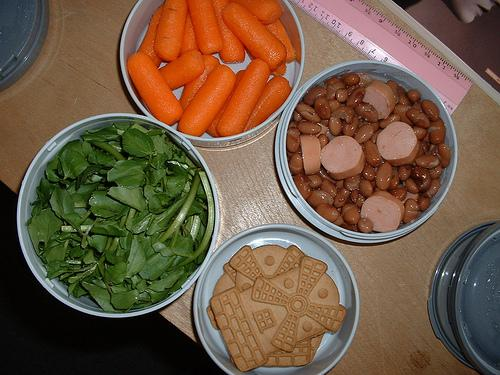What is the cookie in the shape of?

Choices:
A) windmill
B) apple
C) cat
D) baby windmill 